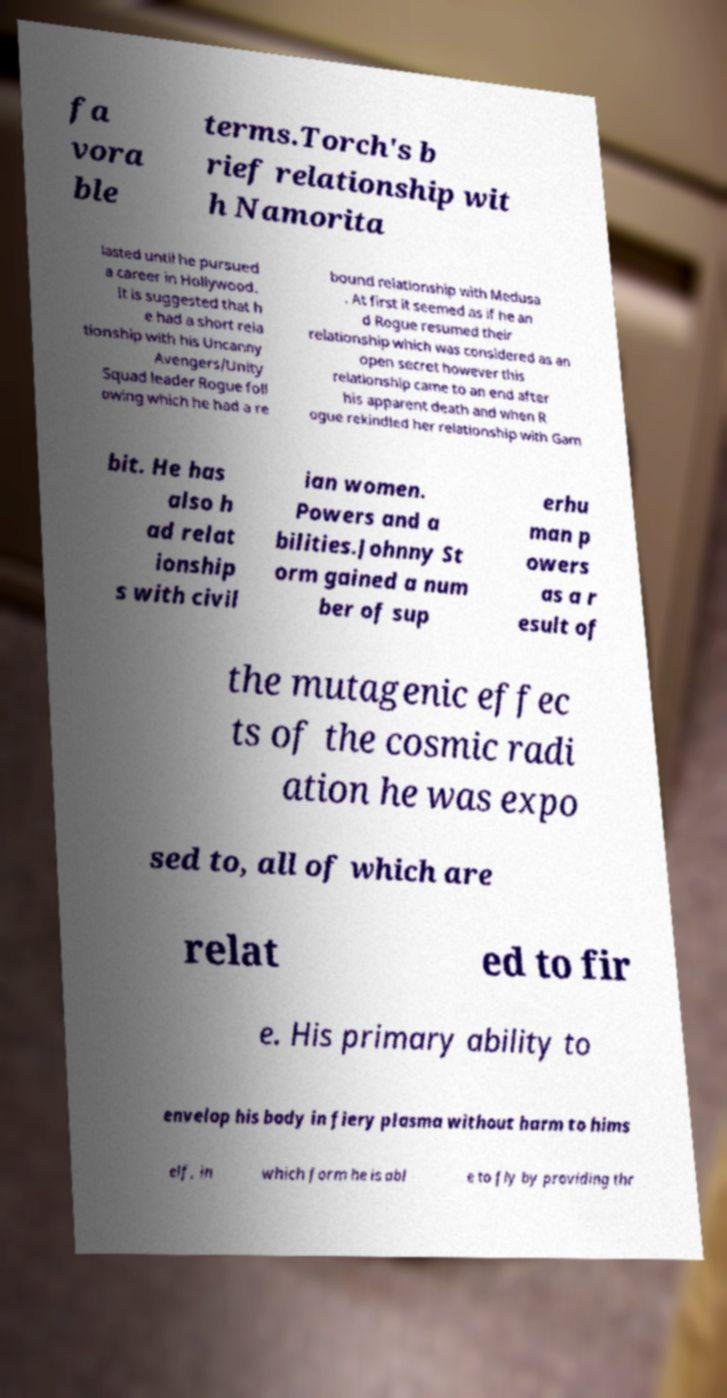Could you extract and type out the text from this image? fa vora ble terms.Torch's b rief relationship wit h Namorita lasted until he pursued a career in Hollywood. It is suggested that h e had a short rela tionship with his Uncanny Avengers/Unity Squad leader Rogue foll owing which he had a re bound relationship with Medusa . At first it seemed as if he an d Rogue resumed their relationship which was considered as an open secret however this relationship came to an end after his apparent death and when R ogue rekindled her relationship with Gam bit. He has also h ad relat ionship s with civil ian women. Powers and a bilities.Johnny St orm gained a num ber of sup erhu man p owers as a r esult of the mutagenic effec ts of the cosmic radi ation he was expo sed to, all of which are relat ed to fir e. His primary ability to envelop his body in fiery plasma without harm to hims elf, in which form he is abl e to fly by providing thr 